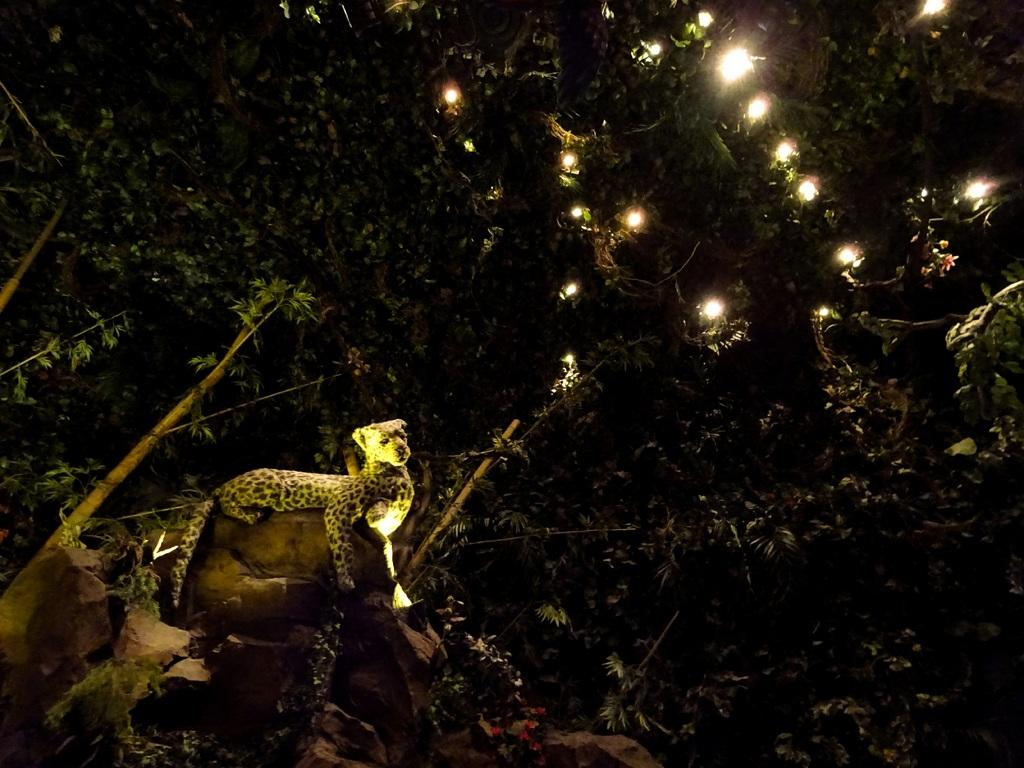What animal is the main subject of the image? There is a cheetah in the image. Where is the cheetah located in the image? The cheetah is sitting on a tree. What can be seen on the tree besides the cheetah? There are lightings on the tree. What type of garden can be seen in the background of the image? There is no garden visible in the image; it features a cheetah sitting on a tree with lightings. 